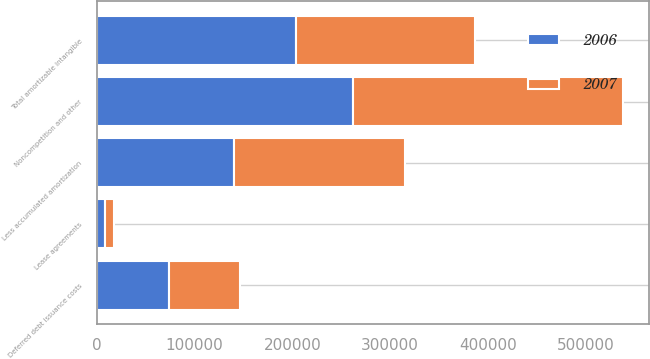<chart> <loc_0><loc_0><loc_500><loc_500><stacked_bar_chart><ecel><fcel>Noncompetition and other<fcel>Lease agreements<fcel>Deferred debt issuance costs<fcel>Less accumulated amortization<fcel>Total amortizable intangible<nl><fcel>2007<fcel>276182<fcel>8738<fcel>72618<fcel>174496<fcel>183042<nl><fcel>2006<fcel>261836<fcel>8738<fcel>73826<fcel>140679<fcel>203721<nl></chart> 